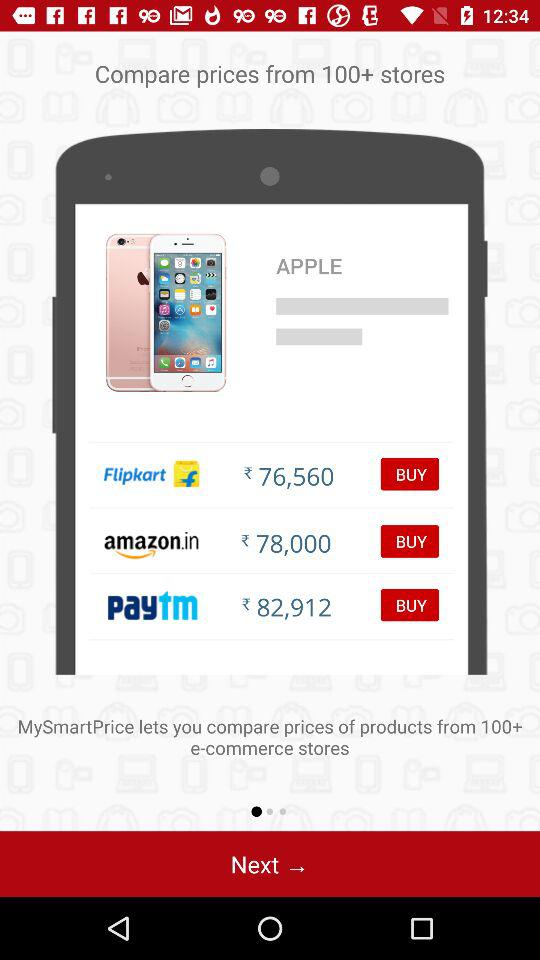Where can I find "MySmartPrice" online?
When the provided information is insufficient, respond with <no answer>. <no answer> 